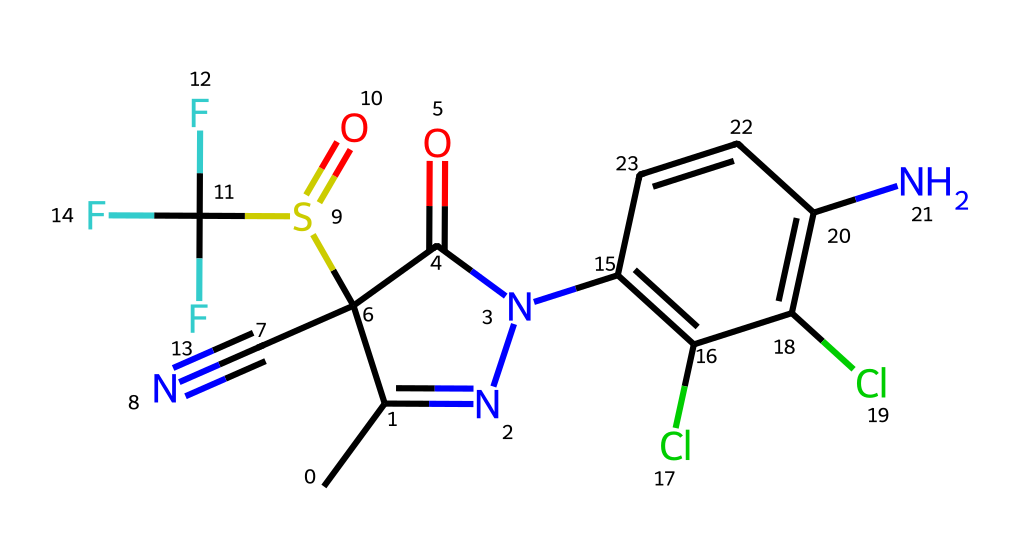What is the main functional group in fipronil? The chemical contains a sulfonyl group (S(=O)) as its main functional group, which is characteristic of pesticides.
Answer: sulfonyl How many nitrogen atoms are present in fipronil? By analyzing the SMILES representation, there are three nitrogen atoms present in the chemical structure.
Answer: three What type of halogen is present in fipronil? The chemical structure contains chlorine (Cl) as the halogen, indicating its potential reactivity and pesticidal properties.
Answer: chlorine What is the significance of the cyano group in fipronil? The cyano group (C#N) contributes to the chemical's lipophilicity, enhancing its absorption and efficacy as a pesticide.
Answer: lipophilicity Which part of fipronil contributes to its insecticidal properties? The combination of the sulfonyl and chloroaryl structures allows for the inhibition of certain neurotransmitter receptors in insects, making it effective as an insecticide.
Answer: neurotransmitter inhibition 